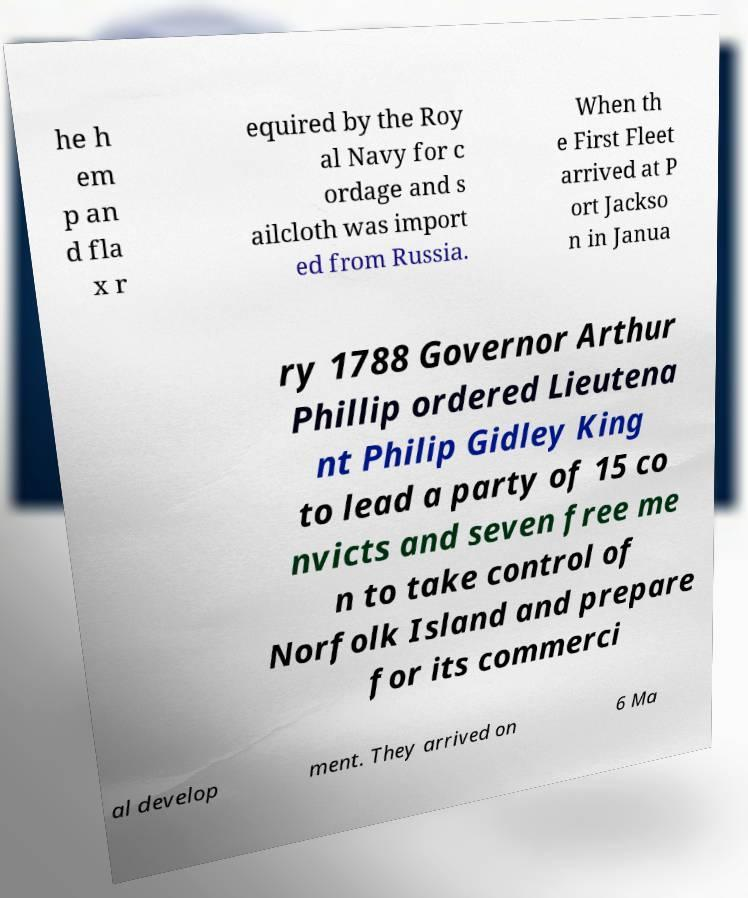I need the written content from this picture converted into text. Can you do that? he h em p an d fla x r equired by the Roy al Navy for c ordage and s ailcloth was import ed from Russia. When th e First Fleet arrived at P ort Jackso n in Janua ry 1788 Governor Arthur Phillip ordered Lieutena nt Philip Gidley King to lead a party of 15 co nvicts and seven free me n to take control of Norfolk Island and prepare for its commerci al develop ment. They arrived on 6 Ma 